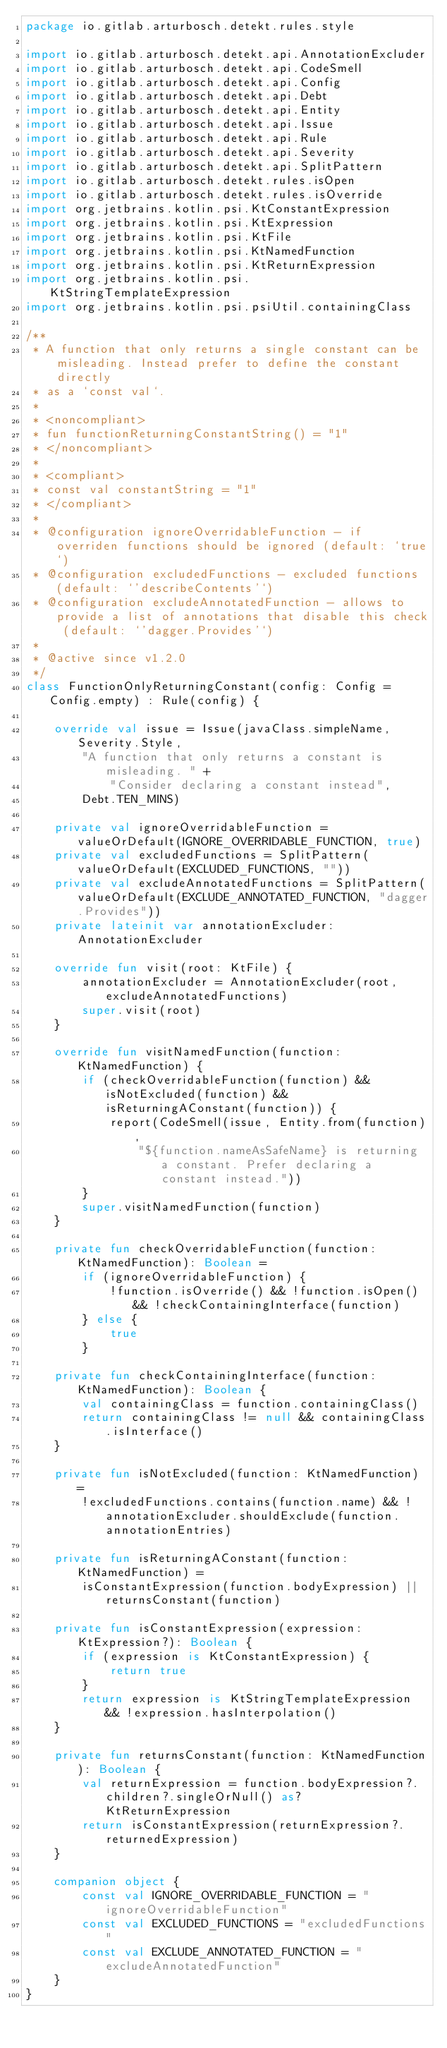Convert code to text. <code><loc_0><loc_0><loc_500><loc_500><_Kotlin_>package io.gitlab.arturbosch.detekt.rules.style

import io.gitlab.arturbosch.detekt.api.AnnotationExcluder
import io.gitlab.arturbosch.detekt.api.CodeSmell
import io.gitlab.arturbosch.detekt.api.Config
import io.gitlab.arturbosch.detekt.api.Debt
import io.gitlab.arturbosch.detekt.api.Entity
import io.gitlab.arturbosch.detekt.api.Issue
import io.gitlab.arturbosch.detekt.api.Rule
import io.gitlab.arturbosch.detekt.api.Severity
import io.gitlab.arturbosch.detekt.api.SplitPattern
import io.gitlab.arturbosch.detekt.rules.isOpen
import io.gitlab.arturbosch.detekt.rules.isOverride
import org.jetbrains.kotlin.psi.KtConstantExpression
import org.jetbrains.kotlin.psi.KtExpression
import org.jetbrains.kotlin.psi.KtFile
import org.jetbrains.kotlin.psi.KtNamedFunction
import org.jetbrains.kotlin.psi.KtReturnExpression
import org.jetbrains.kotlin.psi.KtStringTemplateExpression
import org.jetbrains.kotlin.psi.psiUtil.containingClass

/**
 * A function that only returns a single constant can be misleading. Instead prefer to define the constant directly
 * as a `const val`.
 *
 * <noncompliant>
 * fun functionReturningConstantString() = "1"
 * </noncompliant>
 *
 * <compliant>
 * const val constantString = "1"
 * </compliant>
 *
 * @configuration ignoreOverridableFunction - if overriden functions should be ignored (default: `true`)
 * @configuration excludedFunctions - excluded functions (default: `'describeContents'`)
 * @configuration excludeAnnotatedFunction - allows to provide a list of annotations that disable this check (default: `'dagger.Provides'`)
 *
 * @active since v1.2.0
 */
class FunctionOnlyReturningConstant(config: Config = Config.empty) : Rule(config) {

    override val issue = Issue(javaClass.simpleName, Severity.Style,
        "A function that only returns a constant is misleading. " +
            "Consider declaring a constant instead",
        Debt.TEN_MINS)

    private val ignoreOverridableFunction = valueOrDefault(IGNORE_OVERRIDABLE_FUNCTION, true)
    private val excludedFunctions = SplitPattern(valueOrDefault(EXCLUDED_FUNCTIONS, ""))
    private val excludeAnnotatedFunctions = SplitPattern(valueOrDefault(EXCLUDE_ANNOTATED_FUNCTION, "dagger.Provides"))
    private lateinit var annotationExcluder: AnnotationExcluder

    override fun visit(root: KtFile) {
        annotationExcluder = AnnotationExcluder(root, excludeAnnotatedFunctions)
        super.visit(root)
    }

    override fun visitNamedFunction(function: KtNamedFunction) {
        if (checkOverridableFunction(function) && isNotExcluded(function) && isReturningAConstant(function)) {
            report(CodeSmell(issue, Entity.from(function),
                "${function.nameAsSafeName} is returning a constant. Prefer declaring a constant instead."))
        }
        super.visitNamedFunction(function)
    }

    private fun checkOverridableFunction(function: KtNamedFunction): Boolean =
        if (ignoreOverridableFunction) {
            !function.isOverride() && !function.isOpen() && !checkContainingInterface(function)
        } else {
            true
        }

    private fun checkContainingInterface(function: KtNamedFunction): Boolean {
        val containingClass = function.containingClass()
        return containingClass != null && containingClass.isInterface()
    }

    private fun isNotExcluded(function: KtNamedFunction) =
        !excludedFunctions.contains(function.name) && !annotationExcluder.shouldExclude(function.annotationEntries)

    private fun isReturningAConstant(function: KtNamedFunction) =
        isConstantExpression(function.bodyExpression) || returnsConstant(function)

    private fun isConstantExpression(expression: KtExpression?): Boolean {
        if (expression is KtConstantExpression) {
            return true
        }
        return expression is KtStringTemplateExpression && !expression.hasInterpolation()
    }

    private fun returnsConstant(function: KtNamedFunction): Boolean {
        val returnExpression = function.bodyExpression?.children?.singleOrNull() as? KtReturnExpression
        return isConstantExpression(returnExpression?.returnedExpression)
    }

    companion object {
        const val IGNORE_OVERRIDABLE_FUNCTION = "ignoreOverridableFunction"
        const val EXCLUDED_FUNCTIONS = "excludedFunctions"
        const val EXCLUDE_ANNOTATED_FUNCTION = "excludeAnnotatedFunction"
    }
}
</code> 